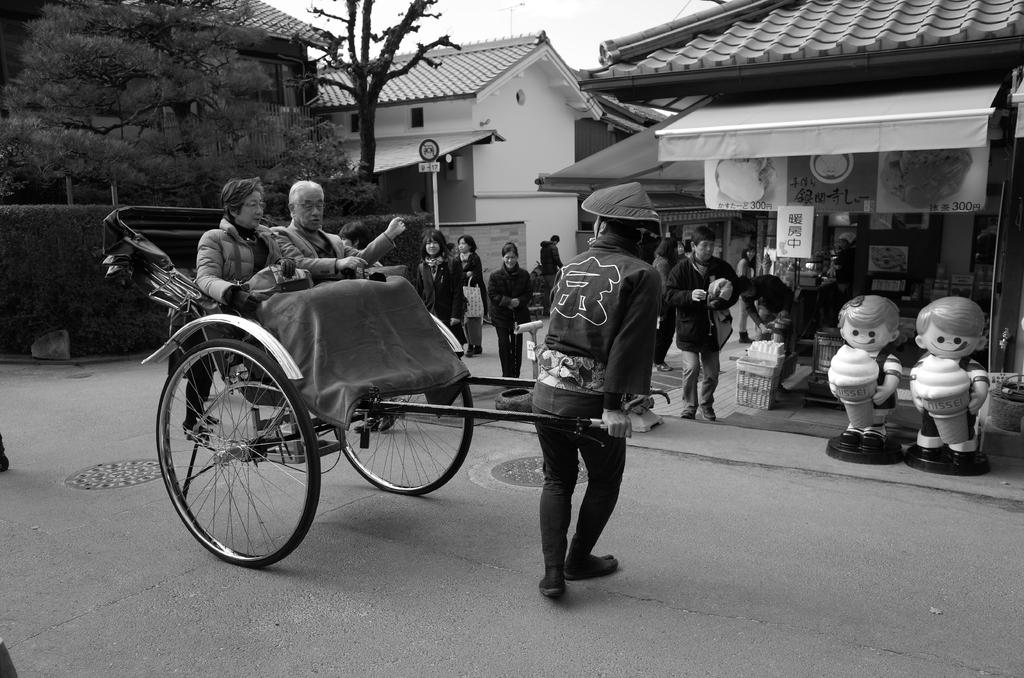Who or what can be seen in the image? There are people in the image. What type of structures are visible in the image? There are houses in the image. What other natural elements can be seen in the image? There are trees in the image. What is the color scheme of the image? The image is in black and white color. What type of throat condition can be seen in the image? There is no reference to any throat condition in the image; it features people, houses, and trees in black and white. What story is being told in the image? There is no story being told in the image; it is a static image of people, houses, and trees. 